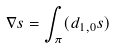<formula> <loc_0><loc_0><loc_500><loc_500>\nabla s = \int _ { \pi } ( d _ { 1 , 0 } s )</formula> 